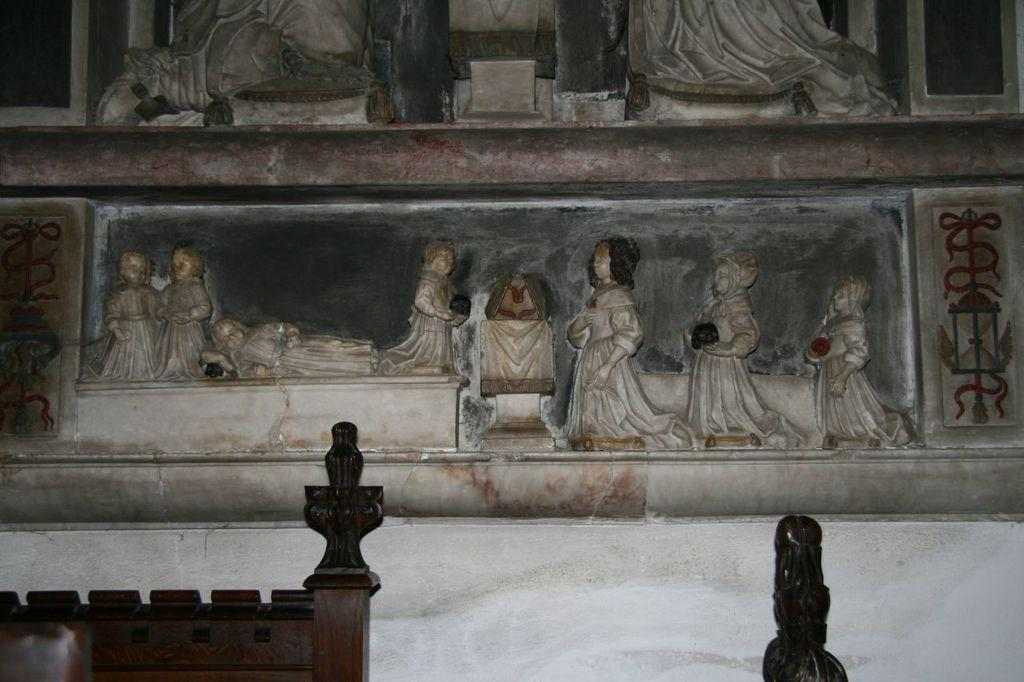What type of art is featured in the image? There are sculptures in the image. Where are the sculptures located? The sculptures are on a wall. How many trips did the artist take to create the sculptures in the image? There is no information about the artist or any trips in the image, so it cannot be determined. What color are the eyes of the sculptures in the image? There are no eyes present on the sculptures in the image, as they are not human or animal figures. 